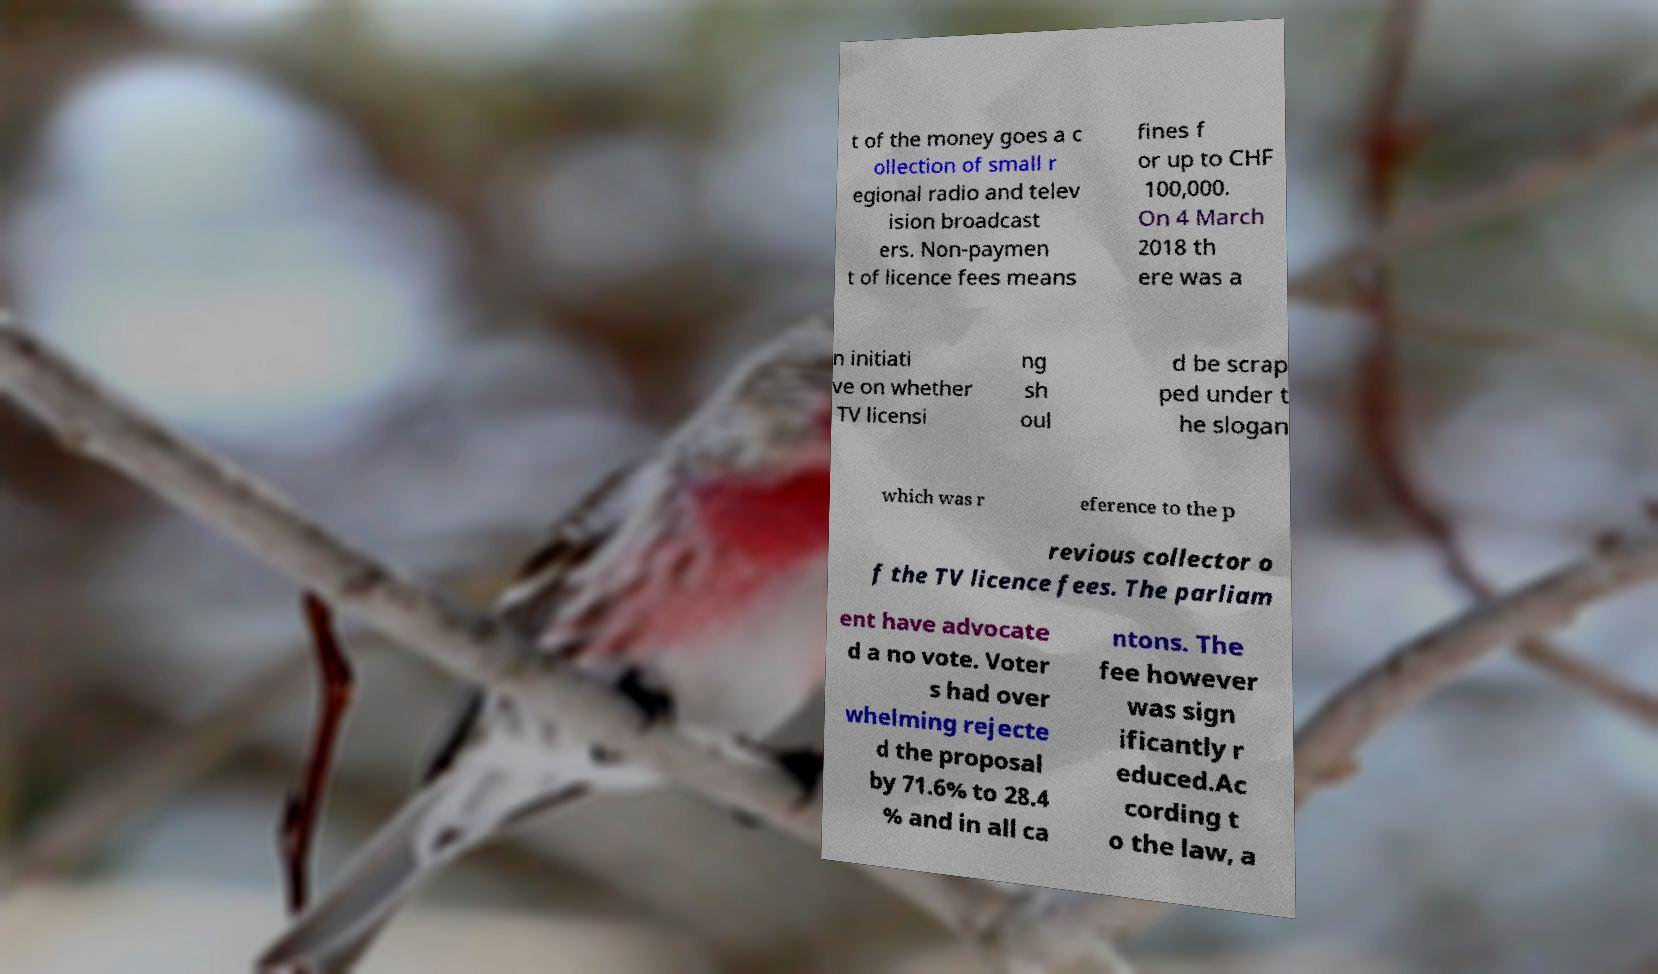Could you extract and type out the text from this image? t of the money goes a c ollection of small r egional radio and telev ision broadcast ers. Non-paymen t of licence fees means fines f or up to CHF 100,000. On 4 March 2018 th ere was a n initiati ve on whether TV licensi ng sh oul d be scrap ped under t he slogan which was r eference to the p revious collector o f the TV licence fees. The parliam ent have advocate d a no vote. Voter s had over whelming rejecte d the proposal by 71.6% to 28.4 % and in all ca ntons. The fee however was sign ificantly r educed.Ac cording t o the law, a 